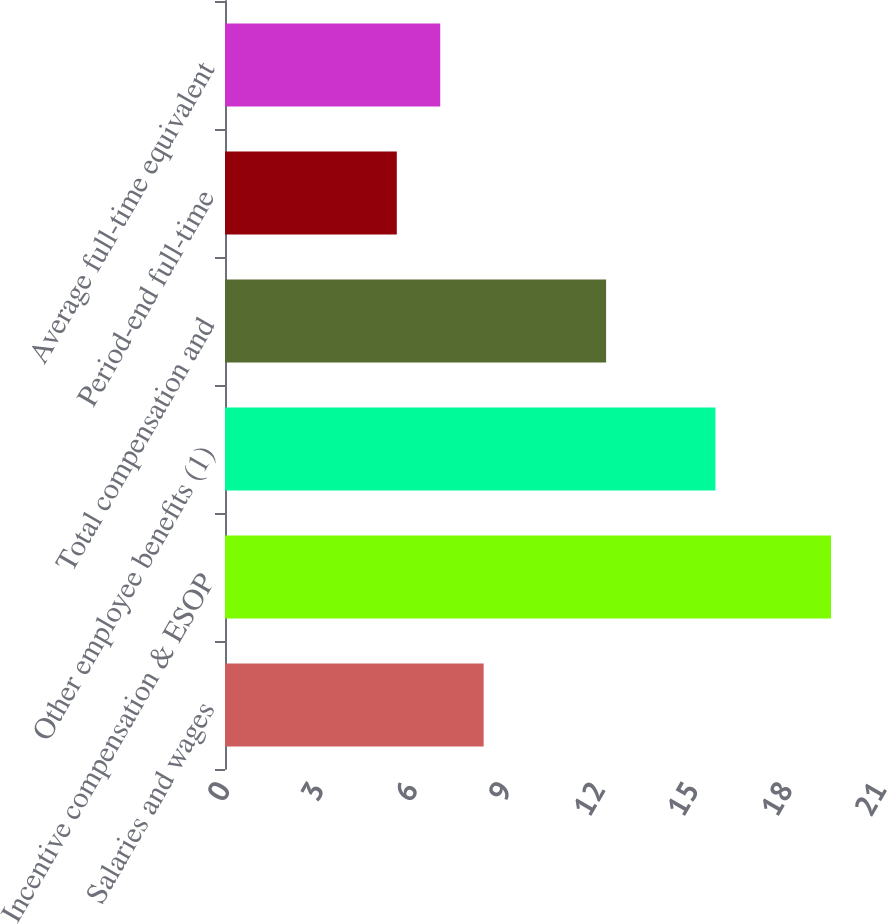Convert chart. <chart><loc_0><loc_0><loc_500><loc_500><bar_chart><fcel>Salaries and wages<fcel>Incentive compensation & ESOP<fcel>Other employee benefits (1)<fcel>Total compensation and<fcel>Period-end full-time<fcel>Average full-time equivalent<nl><fcel>8.28<fcel>19.4<fcel>15.7<fcel>12.2<fcel>5.5<fcel>6.89<nl></chart> 